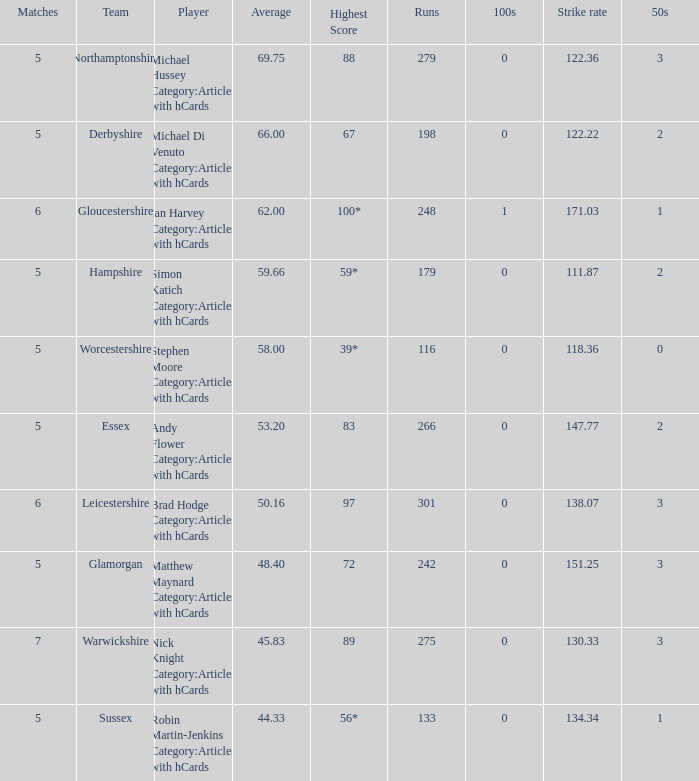If the team is Worcestershire and the Matched had were 5, what is the highest score? 39*. 